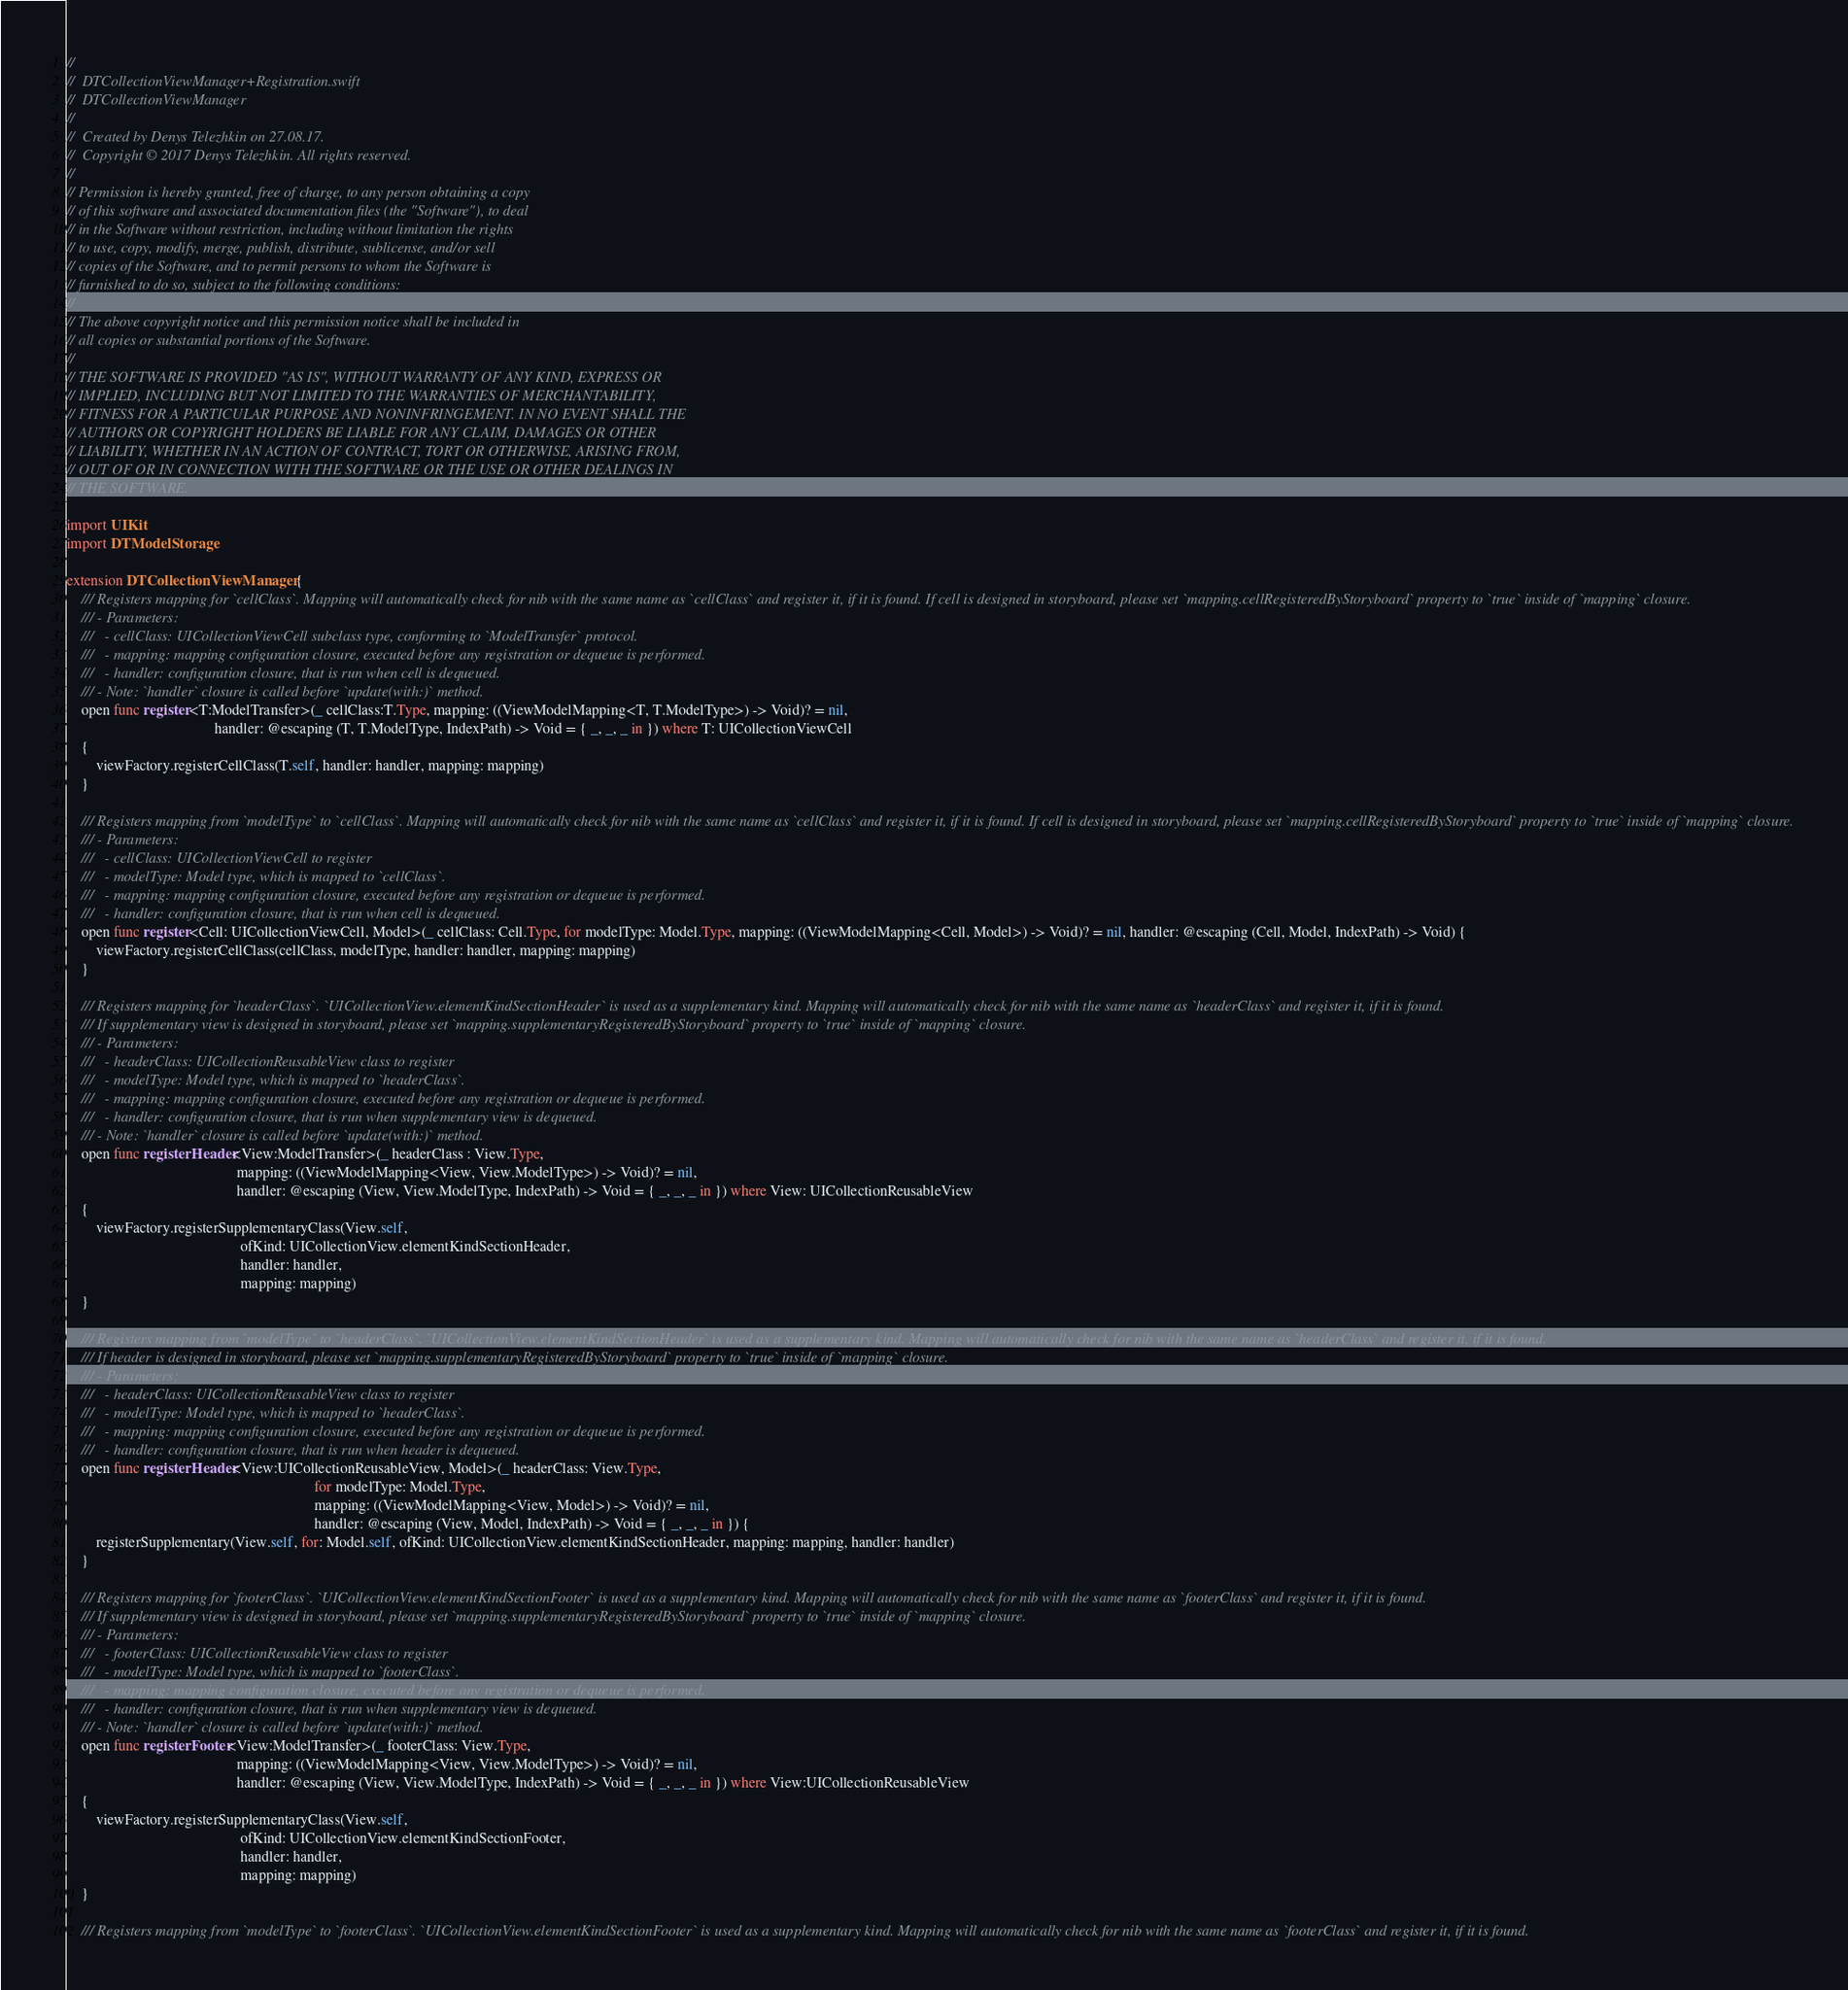Convert code to text. <code><loc_0><loc_0><loc_500><loc_500><_Swift_>//
//  DTCollectionViewManager+Registration.swift
//  DTCollectionViewManager
//
//  Created by Denys Telezhkin on 27.08.17.
//  Copyright © 2017 Denys Telezhkin. All rights reserved.
//
// Permission is hereby granted, free of charge, to any person obtaining a copy
// of this software and associated documentation files (the "Software"), to deal
// in the Software without restriction, including without limitation the rights
// to use, copy, modify, merge, publish, distribute, sublicense, and/or sell
// copies of the Software, and to permit persons to whom the Software is
// furnished to do so, subject to the following conditions:
//
// The above copyright notice and this permission notice shall be included in
// all copies or substantial portions of the Software.
//
// THE SOFTWARE IS PROVIDED "AS IS", WITHOUT WARRANTY OF ANY KIND, EXPRESS OR
// IMPLIED, INCLUDING BUT NOT LIMITED TO THE WARRANTIES OF MERCHANTABILITY,
// FITNESS FOR A PARTICULAR PURPOSE AND NONINFRINGEMENT. IN NO EVENT SHALL THE
// AUTHORS OR COPYRIGHT HOLDERS BE LIABLE FOR ANY CLAIM, DAMAGES OR OTHER
// LIABILITY, WHETHER IN AN ACTION OF CONTRACT, TORT OR OTHERWISE, ARISING FROM,
// OUT OF OR IN CONNECTION WITH THE SOFTWARE OR THE USE OR OTHER DEALINGS IN
// THE SOFTWARE.

import UIKit
import DTModelStorage

extension DTCollectionViewManager {
    /// Registers mapping for `cellClass`. Mapping will automatically check for nib with the same name as `cellClass` and register it, if it is found. If cell is designed in storyboard, please set `mapping.cellRegisteredByStoryboard` property to `true` inside of `mapping` closure.
    /// - Parameters:
    ///   - cellClass: UICollectionViewCell subclass type, conforming to `ModelTransfer` protocol.
    ///   - mapping: mapping configuration closure, executed before any registration or dequeue is performed.
    ///   - handler: configuration closure, that is run when cell is dequeued.
    /// - Note: `handler` closure is called before `update(with:)` method.
    open func register<T:ModelTransfer>(_ cellClass:T.Type, mapping: ((ViewModelMapping<T, T.ModelType>) -> Void)? = nil,
                                        handler: @escaping (T, T.ModelType, IndexPath) -> Void = { _, _, _ in }) where T: UICollectionViewCell
    {
        viewFactory.registerCellClass(T.self, handler: handler, mapping: mapping)
    }
    
    /// Registers mapping from `modelType` to `cellClass`. Mapping will automatically check for nib with the same name as `cellClass` and register it, if it is found. If cell is designed in storyboard, please set `mapping.cellRegisteredByStoryboard` property to `true` inside of `mapping` closure.
    /// - Parameters:
    ///   - cellClass: UICollectionViewCell to register
    ///   - modelType: Model type, which is mapped to `cellClass`.
    ///   - mapping: mapping configuration closure, executed before any registration or dequeue is performed.
    ///   - handler: configuration closure, that is run when cell is dequeued.
    open func register<Cell: UICollectionViewCell, Model>(_ cellClass: Cell.Type, for modelType: Model.Type, mapping: ((ViewModelMapping<Cell, Model>) -> Void)? = nil, handler: @escaping (Cell, Model, IndexPath) -> Void) {
        viewFactory.registerCellClass(cellClass, modelType, handler: handler, mapping: mapping)
    }

    /// Registers mapping for `headerClass`. `UICollectionView.elementKindSectionHeader` is used as a supplementary kind. Mapping will automatically check for nib with the same name as `headerClass` and register it, if it is found.
    /// If supplementary view is designed in storyboard, please set `mapping.supplementaryRegisteredByStoryboard` property to `true` inside of `mapping` closure.
    /// - Parameters:
    ///   - headerClass: UICollectionReusableView class to register
    ///   - modelType: Model type, which is mapped to `headerClass`.
    ///   - mapping: mapping configuration closure, executed before any registration or dequeue is performed.
    ///   - handler: configuration closure, that is run when supplementary view is dequeued.
    /// - Note: `handler` closure is called before `update(with:)` method.
    open func registerHeader<View:ModelTransfer>(_ headerClass : View.Type,
                                              mapping: ((ViewModelMapping<View, View.ModelType>) -> Void)? = nil,
                                              handler: @escaping (View, View.ModelType, IndexPath) -> Void = { _, _, _ in }) where View: UICollectionReusableView
    {
        viewFactory.registerSupplementaryClass(View.self,
                                               ofKind: UICollectionView.elementKindSectionHeader,
                                               handler: handler,
                                               mapping: mapping)
    }
    
    /// Registers mapping from `modelType` to `headerClass`. `UICollectionView.elementKindSectionHeader` is used as a supplementary kind. Mapping will automatically check for nib with the same name as `headerClass` and register it, if it is found.
    /// If header is designed in storyboard, please set `mapping.supplementaryRegisteredByStoryboard` property to `true` inside of `mapping` closure.
    /// - Parameters:
    ///   - headerClass: UICollectionReusableView class to register
    ///   - modelType: Model type, which is mapped to `headerClass`.
    ///   - mapping: mapping configuration closure, executed before any registration or dequeue is performed.
    ///   - handler: configuration closure, that is run when header is dequeued.
    open func registerHeader<View:UICollectionReusableView, Model>(_ headerClass: View.Type,
                                                                   for modelType: Model.Type,
                                                                   mapping: ((ViewModelMapping<View, Model>) -> Void)? = nil,
                                                                   handler: @escaping (View, Model, IndexPath) -> Void = { _, _, _ in }) {
        registerSupplementary(View.self, for: Model.self, ofKind: UICollectionView.elementKindSectionHeader, mapping: mapping, handler: handler)
    }
    
    /// Registers mapping for `footerClass`. `UICollectionView.elementKindSectionFooter` is used as a supplementary kind. Mapping will automatically check for nib with the same name as `footerClass` and register it, if it is found.
    /// If supplementary view is designed in storyboard, please set `mapping.supplementaryRegisteredByStoryboard` property to `true` inside of `mapping` closure.
    /// - Parameters:
    ///   - footerClass: UICollectionReusableView class to register
    ///   - modelType: Model type, which is mapped to `footerClass`.
    ///   - mapping: mapping configuration closure, executed before any registration or dequeue is performed.
    ///   - handler: configuration closure, that is run when supplementary view is dequeued.
    /// - Note: `handler` closure is called before `update(with:)` method.
    open func registerFooter<View:ModelTransfer>(_ footerClass: View.Type,
                                              mapping: ((ViewModelMapping<View, View.ModelType>) -> Void)? = nil,
                                              handler: @escaping (View, View.ModelType, IndexPath) -> Void = { _, _, _ in }) where View:UICollectionReusableView
    {
        viewFactory.registerSupplementaryClass(View.self,
                                               ofKind: UICollectionView.elementKindSectionFooter,
                                               handler: handler,
                                               mapping: mapping)
    }
    
    /// Registers mapping from `modelType` to `footerClass`. `UICollectionView.elementKindSectionFooter` is used as a supplementary kind. Mapping will automatically check for nib with the same name as `footerClass` and register it, if it is found.</code> 